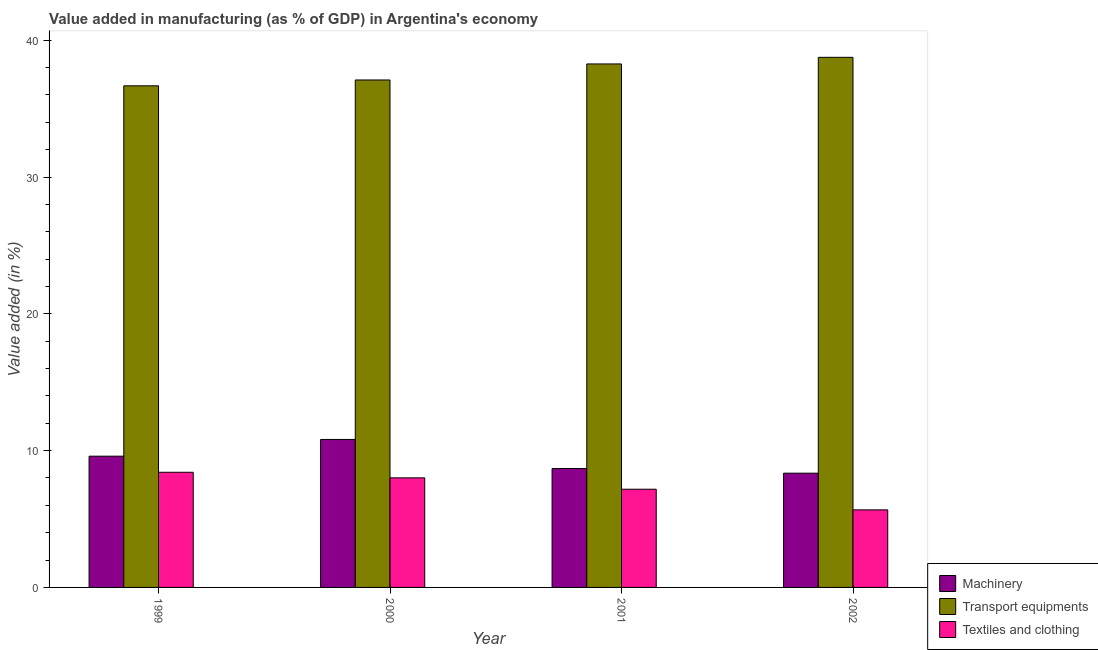How many groups of bars are there?
Make the answer very short. 4. What is the value added in manufacturing machinery in 2000?
Provide a short and direct response. 10.82. Across all years, what is the maximum value added in manufacturing textile and clothing?
Your answer should be compact. 8.42. Across all years, what is the minimum value added in manufacturing transport equipments?
Provide a short and direct response. 36.67. In which year was the value added in manufacturing textile and clothing maximum?
Offer a very short reply. 1999. What is the total value added in manufacturing machinery in the graph?
Make the answer very short. 37.45. What is the difference between the value added in manufacturing transport equipments in 1999 and that in 2001?
Provide a short and direct response. -1.6. What is the difference between the value added in manufacturing textile and clothing in 2000 and the value added in manufacturing transport equipments in 2002?
Your answer should be very brief. 2.34. What is the average value added in manufacturing transport equipments per year?
Ensure brevity in your answer.  37.69. What is the ratio of the value added in manufacturing textile and clothing in 1999 to that in 2002?
Offer a terse response. 1.48. What is the difference between the highest and the second highest value added in manufacturing transport equipments?
Provide a succinct answer. 0.48. What is the difference between the highest and the lowest value added in manufacturing machinery?
Give a very brief answer. 2.47. In how many years, is the value added in manufacturing transport equipments greater than the average value added in manufacturing transport equipments taken over all years?
Your answer should be very brief. 2. Is the sum of the value added in manufacturing textile and clothing in 2001 and 2002 greater than the maximum value added in manufacturing machinery across all years?
Give a very brief answer. Yes. What does the 3rd bar from the left in 2001 represents?
Give a very brief answer. Textiles and clothing. What does the 3rd bar from the right in 1999 represents?
Provide a short and direct response. Machinery. Is it the case that in every year, the sum of the value added in manufacturing machinery and value added in manufacturing transport equipments is greater than the value added in manufacturing textile and clothing?
Your answer should be very brief. Yes. How many bars are there?
Offer a terse response. 12. Are all the bars in the graph horizontal?
Your response must be concise. No. How many years are there in the graph?
Ensure brevity in your answer.  4. Where does the legend appear in the graph?
Offer a terse response. Bottom right. How are the legend labels stacked?
Your answer should be very brief. Vertical. What is the title of the graph?
Your response must be concise. Value added in manufacturing (as % of GDP) in Argentina's economy. What is the label or title of the Y-axis?
Your response must be concise. Value added (in %). What is the Value added (in %) in Machinery in 1999?
Give a very brief answer. 9.59. What is the Value added (in %) in Transport equipments in 1999?
Offer a terse response. 36.67. What is the Value added (in %) of Textiles and clothing in 1999?
Give a very brief answer. 8.42. What is the Value added (in %) of Machinery in 2000?
Provide a short and direct response. 10.82. What is the Value added (in %) in Transport equipments in 2000?
Offer a terse response. 37.09. What is the Value added (in %) in Textiles and clothing in 2000?
Your response must be concise. 8.01. What is the Value added (in %) of Machinery in 2001?
Provide a succinct answer. 8.69. What is the Value added (in %) in Transport equipments in 2001?
Ensure brevity in your answer.  38.26. What is the Value added (in %) of Textiles and clothing in 2001?
Give a very brief answer. 7.18. What is the Value added (in %) in Machinery in 2002?
Make the answer very short. 8.35. What is the Value added (in %) in Transport equipments in 2002?
Offer a terse response. 38.75. What is the Value added (in %) of Textiles and clothing in 2002?
Ensure brevity in your answer.  5.67. Across all years, what is the maximum Value added (in %) of Machinery?
Ensure brevity in your answer.  10.82. Across all years, what is the maximum Value added (in %) in Transport equipments?
Your answer should be very brief. 38.75. Across all years, what is the maximum Value added (in %) in Textiles and clothing?
Make the answer very short. 8.42. Across all years, what is the minimum Value added (in %) in Machinery?
Keep it short and to the point. 8.35. Across all years, what is the minimum Value added (in %) in Transport equipments?
Provide a short and direct response. 36.67. Across all years, what is the minimum Value added (in %) in Textiles and clothing?
Keep it short and to the point. 5.67. What is the total Value added (in %) in Machinery in the graph?
Offer a terse response. 37.45. What is the total Value added (in %) in Transport equipments in the graph?
Provide a succinct answer. 150.77. What is the total Value added (in %) of Textiles and clothing in the graph?
Offer a very short reply. 29.27. What is the difference between the Value added (in %) in Machinery in 1999 and that in 2000?
Give a very brief answer. -1.22. What is the difference between the Value added (in %) of Transport equipments in 1999 and that in 2000?
Give a very brief answer. -0.43. What is the difference between the Value added (in %) in Textiles and clothing in 1999 and that in 2000?
Offer a very short reply. 0.41. What is the difference between the Value added (in %) in Machinery in 1999 and that in 2001?
Give a very brief answer. 0.9. What is the difference between the Value added (in %) in Transport equipments in 1999 and that in 2001?
Keep it short and to the point. -1.6. What is the difference between the Value added (in %) in Textiles and clothing in 1999 and that in 2001?
Ensure brevity in your answer.  1.24. What is the difference between the Value added (in %) of Machinery in 1999 and that in 2002?
Your response must be concise. 1.24. What is the difference between the Value added (in %) of Transport equipments in 1999 and that in 2002?
Give a very brief answer. -2.08. What is the difference between the Value added (in %) of Textiles and clothing in 1999 and that in 2002?
Provide a short and direct response. 2.75. What is the difference between the Value added (in %) of Machinery in 2000 and that in 2001?
Provide a short and direct response. 2.13. What is the difference between the Value added (in %) of Transport equipments in 2000 and that in 2001?
Provide a short and direct response. -1.17. What is the difference between the Value added (in %) in Textiles and clothing in 2000 and that in 2001?
Offer a very short reply. 0.83. What is the difference between the Value added (in %) in Machinery in 2000 and that in 2002?
Offer a very short reply. 2.47. What is the difference between the Value added (in %) in Transport equipments in 2000 and that in 2002?
Provide a succinct answer. -1.66. What is the difference between the Value added (in %) of Textiles and clothing in 2000 and that in 2002?
Your response must be concise. 2.34. What is the difference between the Value added (in %) in Machinery in 2001 and that in 2002?
Make the answer very short. 0.34. What is the difference between the Value added (in %) in Transport equipments in 2001 and that in 2002?
Your answer should be compact. -0.48. What is the difference between the Value added (in %) in Textiles and clothing in 2001 and that in 2002?
Your answer should be compact. 1.51. What is the difference between the Value added (in %) in Machinery in 1999 and the Value added (in %) in Transport equipments in 2000?
Your answer should be very brief. -27.5. What is the difference between the Value added (in %) in Machinery in 1999 and the Value added (in %) in Textiles and clothing in 2000?
Offer a very short reply. 1.58. What is the difference between the Value added (in %) of Transport equipments in 1999 and the Value added (in %) of Textiles and clothing in 2000?
Make the answer very short. 28.66. What is the difference between the Value added (in %) in Machinery in 1999 and the Value added (in %) in Transport equipments in 2001?
Your response must be concise. -28.67. What is the difference between the Value added (in %) of Machinery in 1999 and the Value added (in %) of Textiles and clothing in 2001?
Keep it short and to the point. 2.42. What is the difference between the Value added (in %) of Transport equipments in 1999 and the Value added (in %) of Textiles and clothing in 2001?
Your answer should be compact. 29.49. What is the difference between the Value added (in %) in Machinery in 1999 and the Value added (in %) in Transport equipments in 2002?
Provide a short and direct response. -29.15. What is the difference between the Value added (in %) in Machinery in 1999 and the Value added (in %) in Textiles and clothing in 2002?
Keep it short and to the point. 3.92. What is the difference between the Value added (in %) in Transport equipments in 1999 and the Value added (in %) in Textiles and clothing in 2002?
Make the answer very short. 31. What is the difference between the Value added (in %) of Machinery in 2000 and the Value added (in %) of Transport equipments in 2001?
Make the answer very short. -27.45. What is the difference between the Value added (in %) in Machinery in 2000 and the Value added (in %) in Textiles and clothing in 2001?
Give a very brief answer. 3.64. What is the difference between the Value added (in %) in Transport equipments in 2000 and the Value added (in %) in Textiles and clothing in 2001?
Your answer should be compact. 29.91. What is the difference between the Value added (in %) of Machinery in 2000 and the Value added (in %) of Transport equipments in 2002?
Your answer should be very brief. -27.93. What is the difference between the Value added (in %) of Machinery in 2000 and the Value added (in %) of Textiles and clothing in 2002?
Keep it short and to the point. 5.15. What is the difference between the Value added (in %) in Transport equipments in 2000 and the Value added (in %) in Textiles and clothing in 2002?
Offer a terse response. 31.42. What is the difference between the Value added (in %) of Machinery in 2001 and the Value added (in %) of Transport equipments in 2002?
Your response must be concise. -30.06. What is the difference between the Value added (in %) of Machinery in 2001 and the Value added (in %) of Textiles and clothing in 2002?
Your answer should be very brief. 3.02. What is the difference between the Value added (in %) of Transport equipments in 2001 and the Value added (in %) of Textiles and clothing in 2002?
Ensure brevity in your answer.  32.6. What is the average Value added (in %) in Machinery per year?
Provide a short and direct response. 9.36. What is the average Value added (in %) in Transport equipments per year?
Provide a succinct answer. 37.69. What is the average Value added (in %) of Textiles and clothing per year?
Provide a succinct answer. 7.32. In the year 1999, what is the difference between the Value added (in %) of Machinery and Value added (in %) of Transport equipments?
Make the answer very short. -27.07. In the year 1999, what is the difference between the Value added (in %) of Machinery and Value added (in %) of Textiles and clothing?
Your response must be concise. 1.18. In the year 1999, what is the difference between the Value added (in %) in Transport equipments and Value added (in %) in Textiles and clothing?
Provide a short and direct response. 28.25. In the year 2000, what is the difference between the Value added (in %) of Machinery and Value added (in %) of Transport equipments?
Your answer should be compact. -26.28. In the year 2000, what is the difference between the Value added (in %) of Machinery and Value added (in %) of Textiles and clothing?
Offer a terse response. 2.81. In the year 2000, what is the difference between the Value added (in %) of Transport equipments and Value added (in %) of Textiles and clothing?
Provide a succinct answer. 29.08. In the year 2001, what is the difference between the Value added (in %) of Machinery and Value added (in %) of Transport equipments?
Ensure brevity in your answer.  -29.57. In the year 2001, what is the difference between the Value added (in %) in Machinery and Value added (in %) in Textiles and clothing?
Keep it short and to the point. 1.51. In the year 2001, what is the difference between the Value added (in %) in Transport equipments and Value added (in %) in Textiles and clothing?
Make the answer very short. 31.09. In the year 2002, what is the difference between the Value added (in %) in Machinery and Value added (in %) in Transport equipments?
Make the answer very short. -30.4. In the year 2002, what is the difference between the Value added (in %) of Machinery and Value added (in %) of Textiles and clothing?
Your answer should be compact. 2.68. In the year 2002, what is the difference between the Value added (in %) in Transport equipments and Value added (in %) in Textiles and clothing?
Offer a very short reply. 33.08. What is the ratio of the Value added (in %) of Machinery in 1999 to that in 2000?
Make the answer very short. 0.89. What is the ratio of the Value added (in %) in Transport equipments in 1999 to that in 2000?
Your answer should be very brief. 0.99. What is the ratio of the Value added (in %) in Textiles and clothing in 1999 to that in 2000?
Your answer should be compact. 1.05. What is the ratio of the Value added (in %) of Machinery in 1999 to that in 2001?
Your response must be concise. 1.1. What is the ratio of the Value added (in %) of Transport equipments in 1999 to that in 2001?
Your answer should be compact. 0.96. What is the ratio of the Value added (in %) in Textiles and clothing in 1999 to that in 2001?
Keep it short and to the point. 1.17. What is the ratio of the Value added (in %) in Machinery in 1999 to that in 2002?
Provide a short and direct response. 1.15. What is the ratio of the Value added (in %) of Transport equipments in 1999 to that in 2002?
Your answer should be very brief. 0.95. What is the ratio of the Value added (in %) in Textiles and clothing in 1999 to that in 2002?
Provide a short and direct response. 1.48. What is the ratio of the Value added (in %) in Machinery in 2000 to that in 2001?
Ensure brevity in your answer.  1.24. What is the ratio of the Value added (in %) of Transport equipments in 2000 to that in 2001?
Make the answer very short. 0.97. What is the ratio of the Value added (in %) of Textiles and clothing in 2000 to that in 2001?
Your response must be concise. 1.12. What is the ratio of the Value added (in %) in Machinery in 2000 to that in 2002?
Offer a terse response. 1.3. What is the ratio of the Value added (in %) in Transport equipments in 2000 to that in 2002?
Ensure brevity in your answer.  0.96. What is the ratio of the Value added (in %) of Textiles and clothing in 2000 to that in 2002?
Provide a short and direct response. 1.41. What is the ratio of the Value added (in %) of Machinery in 2001 to that in 2002?
Offer a terse response. 1.04. What is the ratio of the Value added (in %) in Transport equipments in 2001 to that in 2002?
Give a very brief answer. 0.99. What is the ratio of the Value added (in %) in Textiles and clothing in 2001 to that in 2002?
Provide a succinct answer. 1.27. What is the difference between the highest and the second highest Value added (in %) in Machinery?
Provide a short and direct response. 1.22. What is the difference between the highest and the second highest Value added (in %) in Transport equipments?
Your answer should be compact. 0.48. What is the difference between the highest and the second highest Value added (in %) in Textiles and clothing?
Offer a very short reply. 0.41. What is the difference between the highest and the lowest Value added (in %) in Machinery?
Your answer should be very brief. 2.47. What is the difference between the highest and the lowest Value added (in %) of Transport equipments?
Keep it short and to the point. 2.08. What is the difference between the highest and the lowest Value added (in %) of Textiles and clothing?
Ensure brevity in your answer.  2.75. 